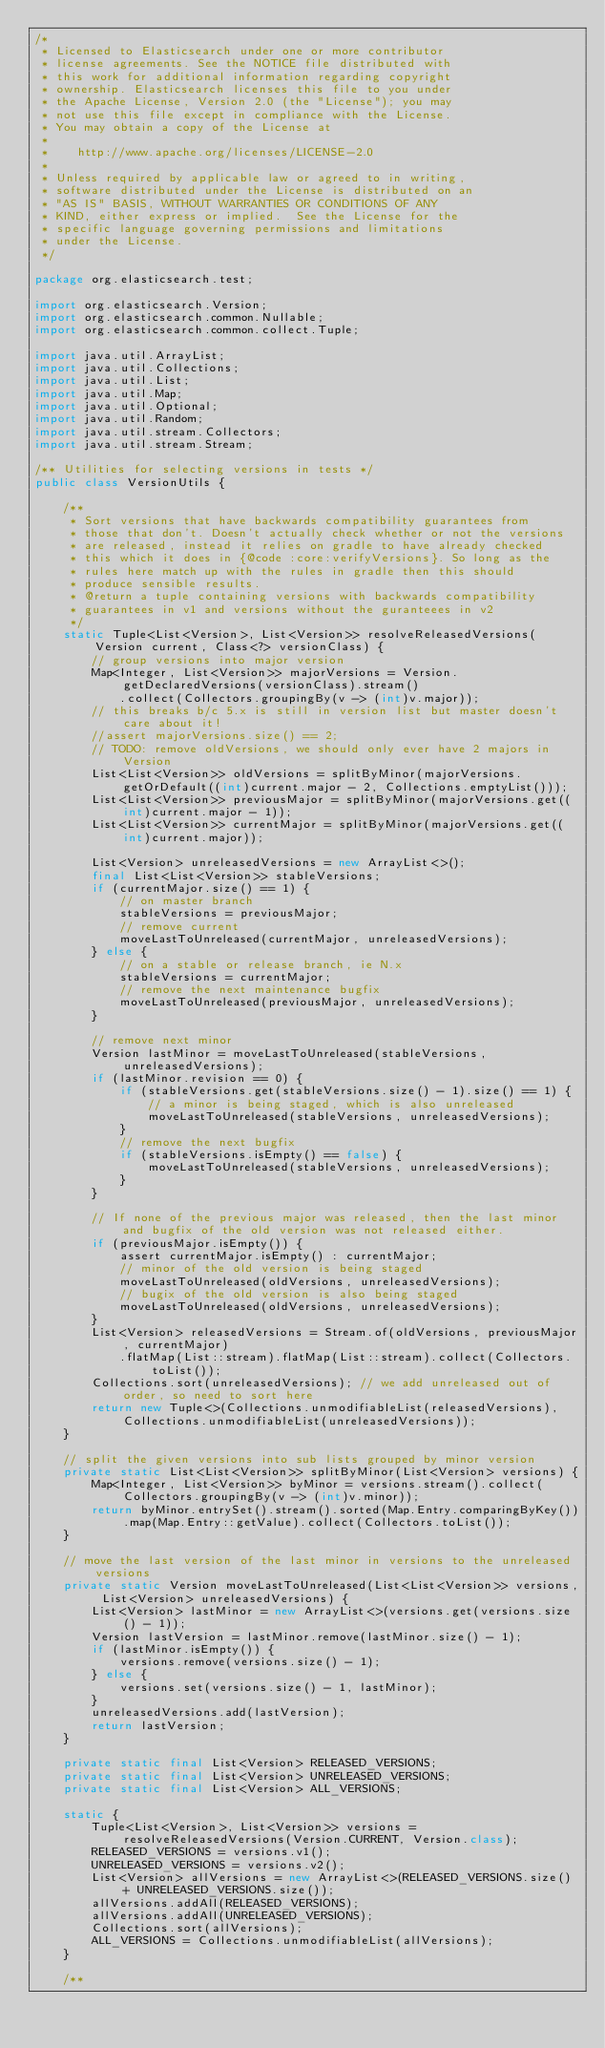<code> <loc_0><loc_0><loc_500><loc_500><_Java_>/*
 * Licensed to Elasticsearch under one or more contributor
 * license agreements. See the NOTICE file distributed with
 * this work for additional information regarding copyright
 * ownership. Elasticsearch licenses this file to you under
 * the Apache License, Version 2.0 (the "License"); you may
 * not use this file except in compliance with the License.
 * You may obtain a copy of the License at
 *
 *    http://www.apache.org/licenses/LICENSE-2.0
 *
 * Unless required by applicable law or agreed to in writing,
 * software distributed under the License is distributed on an
 * "AS IS" BASIS, WITHOUT WARRANTIES OR CONDITIONS OF ANY
 * KIND, either express or implied.  See the License for the
 * specific language governing permissions and limitations
 * under the License.
 */

package org.elasticsearch.test;

import org.elasticsearch.Version;
import org.elasticsearch.common.Nullable;
import org.elasticsearch.common.collect.Tuple;

import java.util.ArrayList;
import java.util.Collections;
import java.util.List;
import java.util.Map;
import java.util.Optional;
import java.util.Random;
import java.util.stream.Collectors;
import java.util.stream.Stream;

/** Utilities for selecting versions in tests */
public class VersionUtils {

    /**
     * Sort versions that have backwards compatibility guarantees from
     * those that don't. Doesn't actually check whether or not the versions
     * are released, instead it relies on gradle to have already checked
     * this which it does in {@code :core:verifyVersions}. So long as the
     * rules here match up with the rules in gradle then this should
     * produce sensible results.
     * @return a tuple containing versions with backwards compatibility
     * guarantees in v1 and versions without the guranteees in v2
     */
    static Tuple<List<Version>, List<Version>> resolveReleasedVersions(Version current, Class<?> versionClass) {
        // group versions into major version
        Map<Integer, List<Version>> majorVersions = Version.getDeclaredVersions(versionClass).stream()
            .collect(Collectors.groupingBy(v -> (int)v.major));
        // this breaks b/c 5.x is still in version list but master doesn't care about it!
        //assert majorVersions.size() == 2;
        // TODO: remove oldVersions, we should only ever have 2 majors in Version
        List<List<Version>> oldVersions = splitByMinor(majorVersions.getOrDefault((int)current.major - 2, Collections.emptyList()));
        List<List<Version>> previousMajor = splitByMinor(majorVersions.get((int)current.major - 1));
        List<List<Version>> currentMajor = splitByMinor(majorVersions.get((int)current.major));

        List<Version> unreleasedVersions = new ArrayList<>();
        final List<List<Version>> stableVersions;
        if (currentMajor.size() == 1) {
            // on master branch
            stableVersions = previousMajor;
            // remove current
            moveLastToUnreleased(currentMajor, unreleasedVersions);
        } else {
            // on a stable or release branch, ie N.x
            stableVersions = currentMajor;
            // remove the next maintenance bugfix
            moveLastToUnreleased(previousMajor, unreleasedVersions);
        }

        // remove next minor
        Version lastMinor = moveLastToUnreleased(stableVersions, unreleasedVersions);
        if (lastMinor.revision == 0) {
            if (stableVersions.get(stableVersions.size() - 1).size() == 1) {
                // a minor is being staged, which is also unreleased
                moveLastToUnreleased(stableVersions, unreleasedVersions);
            }
            // remove the next bugfix
            if (stableVersions.isEmpty() == false) {
                moveLastToUnreleased(stableVersions, unreleasedVersions);
            }
        }

        // If none of the previous major was released, then the last minor and bugfix of the old version was not released either.
        if (previousMajor.isEmpty()) {
            assert currentMajor.isEmpty() : currentMajor;
            // minor of the old version is being staged
            moveLastToUnreleased(oldVersions, unreleasedVersions);
            // bugix of the old version is also being staged
            moveLastToUnreleased(oldVersions, unreleasedVersions);
        }
        List<Version> releasedVersions = Stream.of(oldVersions, previousMajor, currentMajor)
            .flatMap(List::stream).flatMap(List::stream).collect(Collectors.toList());
        Collections.sort(unreleasedVersions); // we add unreleased out of order, so need to sort here
        return new Tuple<>(Collections.unmodifiableList(releasedVersions), Collections.unmodifiableList(unreleasedVersions));
    }

    // split the given versions into sub lists grouped by minor version
    private static List<List<Version>> splitByMinor(List<Version> versions) {
        Map<Integer, List<Version>> byMinor = versions.stream().collect(Collectors.groupingBy(v -> (int)v.minor));
        return byMinor.entrySet().stream().sorted(Map.Entry.comparingByKey()).map(Map.Entry::getValue).collect(Collectors.toList());
    }

    // move the last version of the last minor in versions to the unreleased versions
    private static Version moveLastToUnreleased(List<List<Version>> versions, List<Version> unreleasedVersions) {
        List<Version> lastMinor = new ArrayList<>(versions.get(versions.size() - 1));
        Version lastVersion = lastMinor.remove(lastMinor.size() - 1);
        if (lastMinor.isEmpty()) {
            versions.remove(versions.size() - 1);
        } else {
            versions.set(versions.size() - 1, lastMinor);
        }
        unreleasedVersions.add(lastVersion);
        return lastVersion;
    }

    private static final List<Version> RELEASED_VERSIONS;
    private static final List<Version> UNRELEASED_VERSIONS;
    private static final List<Version> ALL_VERSIONS;

    static {
        Tuple<List<Version>, List<Version>> versions = resolveReleasedVersions(Version.CURRENT, Version.class);
        RELEASED_VERSIONS = versions.v1();
        UNRELEASED_VERSIONS = versions.v2();
        List<Version> allVersions = new ArrayList<>(RELEASED_VERSIONS.size() + UNRELEASED_VERSIONS.size());
        allVersions.addAll(RELEASED_VERSIONS);
        allVersions.addAll(UNRELEASED_VERSIONS);
        Collections.sort(allVersions);
        ALL_VERSIONS = Collections.unmodifiableList(allVersions);
    }

    /**</code> 